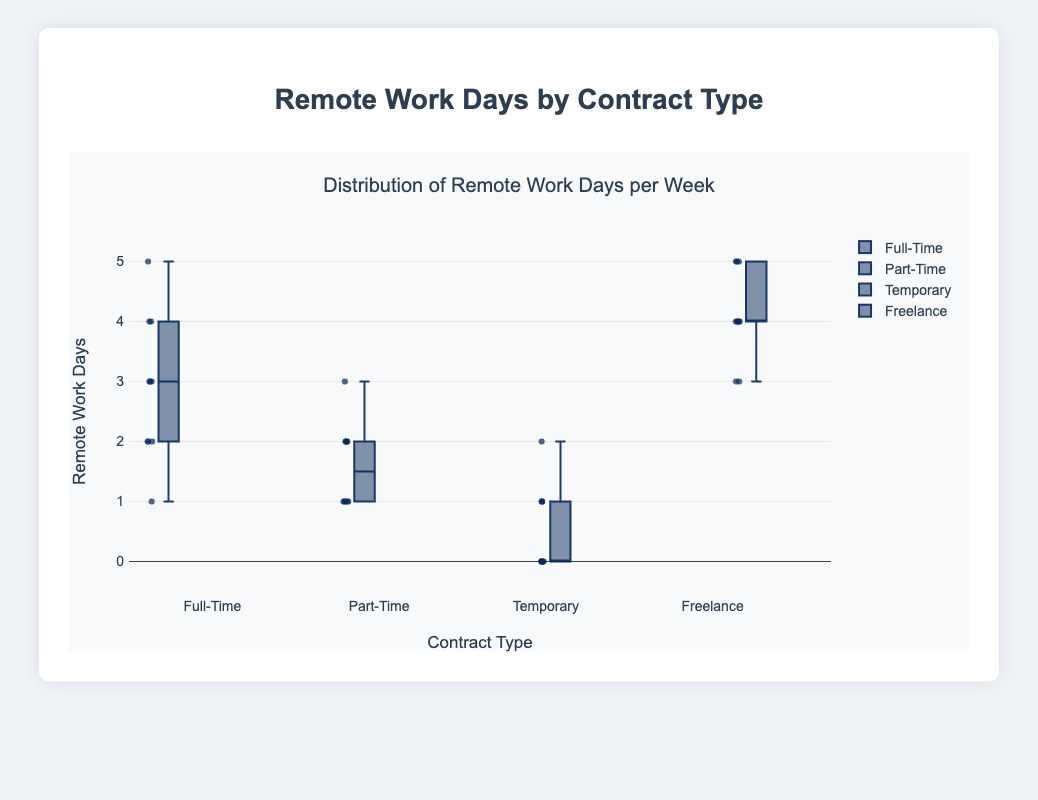What's the title of the figure? The title is located at the top of the figure and provides a summary of what the chart represents. It should be the first prominent text seen in the visualization.
Answer: Remote Work Days by Contract Type What are the contract types shown on the x-axis? The x-axis lists the different categories or groups, which in this case are the types of employment contracts.
Answer: Full-Time, Part-Time, Temporary, Freelance Which contract type has the highest median number of remote work days per week? To find the median, look at the middle line inside each box in the box plot. The highest median will be the one closest to the top of the y-axis.
Answer: Freelance What is the maximum number of remote work days per week for Full-Time employees? The maximum value is the highest point or the top whisker in the Full-Time box plot.
Answer: 5 Which contract type has the lowest median number of remote work days per week? The median line inside the box plot represents the middle value of the dataset. Identify which box plot has the lowest median line.
Answer: Temporary What is the interquartile range (IQR) of remote work days for Freelance workers? The IQR is the difference between the third quartile (top border of the box) and the first quartile (bottom border of the box). Identify those points in the Freelance box plot and subtract the first quartile from the third quartile.
Answer: 1 How does the variability in remote work days compare between Part-Time and Full-Time workers? To compare variability, observe the height of the boxes and the length of the whiskers for both contract types. Larger boxes and longer whiskers indicate higher variability.
Answer: Part-Time has less variability than Full-Time Which contract type shows the least variability in remote work days? The least variability is shown by the contract type whose box and whiskers are the shortest.
Answer: Temporary What is the range of remote work days per week for Part-Time workers? The range is the difference between the maximum and minimum values in the Part-Time box plot. Find the highest and lowest data points and subtract the minimum from the maximum.
Answer: 2 Are there any outliers in the Temporary contract type data? Outliers are points that fall outside the whiskers of the box plot. Look for any points that are isolated from the rest.
Answer: No 